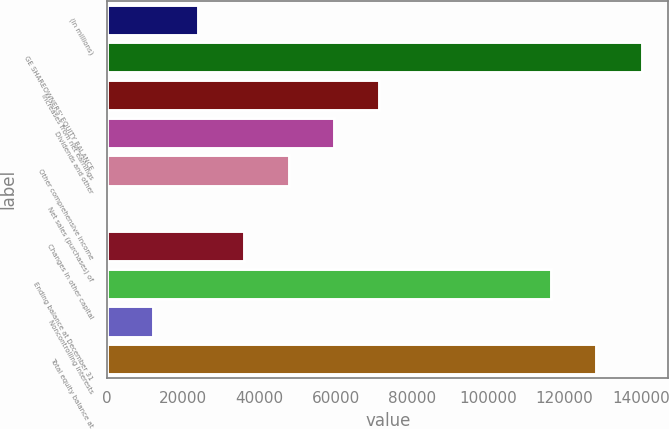<chart> <loc_0><loc_0><loc_500><loc_500><bar_chart><fcel>(In millions)<fcel>GE SHAREOWNERS' EQUITY BALANCE<fcel>Increases from net earnings<fcel>Dividends and other<fcel>Other comprehensive income<fcel>Net sales (purchases) of<fcel>Changes in other capital<fcel>Ending balance at December 31<fcel>Noncontrolling interests<fcel>Total equity balance at<nl><fcel>23922.4<fcel>140191<fcel>71429.2<fcel>59552.5<fcel>47675.8<fcel>169<fcel>35799.1<fcel>116438<fcel>12045.7<fcel>128315<nl></chart> 